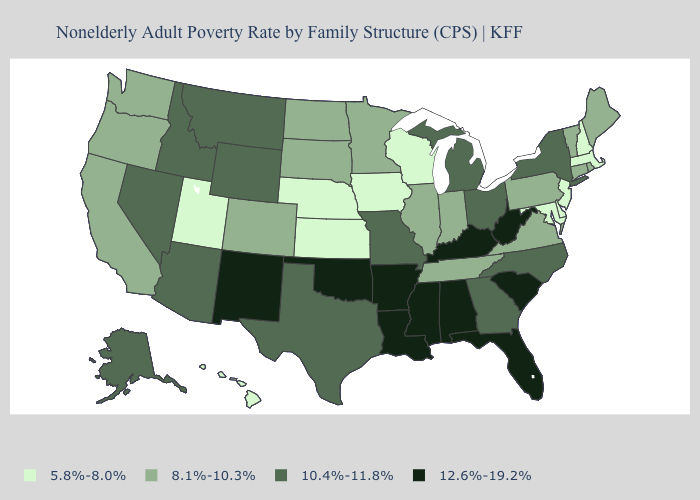What is the value of Florida?
Give a very brief answer. 12.6%-19.2%. What is the highest value in states that border Rhode Island?
Give a very brief answer. 8.1%-10.3%. What is the value of Pennsylvania?
Be succinct. 8.1%-10.3%. Is the legend a continuous bar?
Quick response, please. No. What is the lowest value in the USA?
Answer briefly. 5.8%-8.0%. What is the value of Maine?
Concise answer only. 8.1%-10.3%. What is the highest value in the West ?
Be succinct. 12.6%-19.2%. Name the states that have a value in the range 5.8%-8.0%?
Concise answer only. Delaware, Hawaii, Iowa, Kansas, Maryland, Massachusetts, Nebraska, New Hampshire, New Jersey, Utah, Wisconsin. What is the value of Arkansas?
Short answer required. 12.6%-19.2%. Name the states that have a value in the range 8.1%-10.3%?
Short answer required. California, Colorado, Connecticut, Illinois, Indiana, Maine, Minnesota, North Dakota, Oregon, Pennsylvania, Rhode Island, South Dakota, Tennessee, Vermont, Virginia, Washington. Does the first symbol in the legend represent the smallest category?
Be succinct. Yes. What is the value of New Jersey?
Keep it brief. 5.8%-8.0%. What is the value of New Jersey?
Short answer required. 5.8%-8.0%. What is the lowest value in states that border Maryland?
Be succinct. 5.8%-8.0%. Name the states that have a value in the range 12.6%-19.2%?
Quick response, please. Alabama, Arkansas, Florida, Kentucky, Louisiana, Mississippi, New Mexico, Oklahoma, South Carolina, West Virginia. 